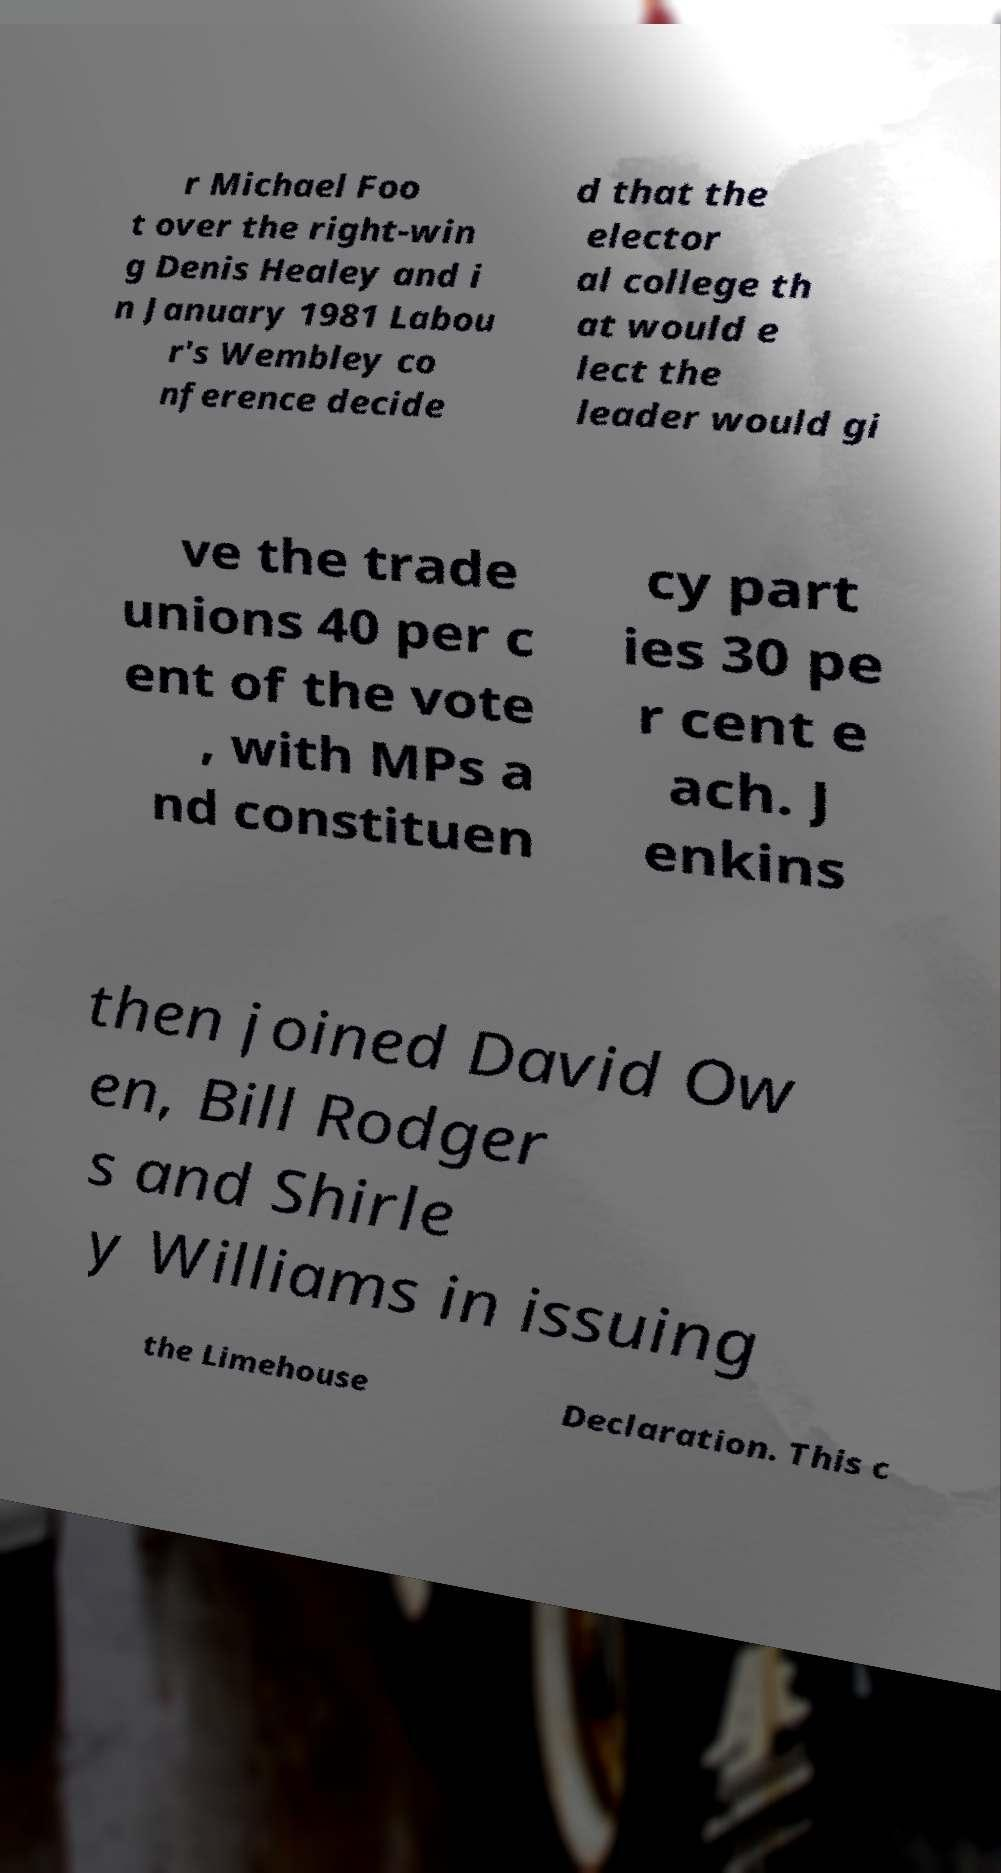Could you assist in decoding the text presented in this image and type it out clearly? r Michael Foo t over the right-win g Denis Healey and i n January 1981 Labou r's Wembley co nference decide d that the elector al college th at would e lect the leader would gi ve the trade unions 40 per c ent of the vote , with MPs a nd constituen cy part ies 30 pe r cent e ach. J enkins then joined David Ow en, Bill Rodger s and Shirle y Williams in issuing the Limehouse Declaration. This c 